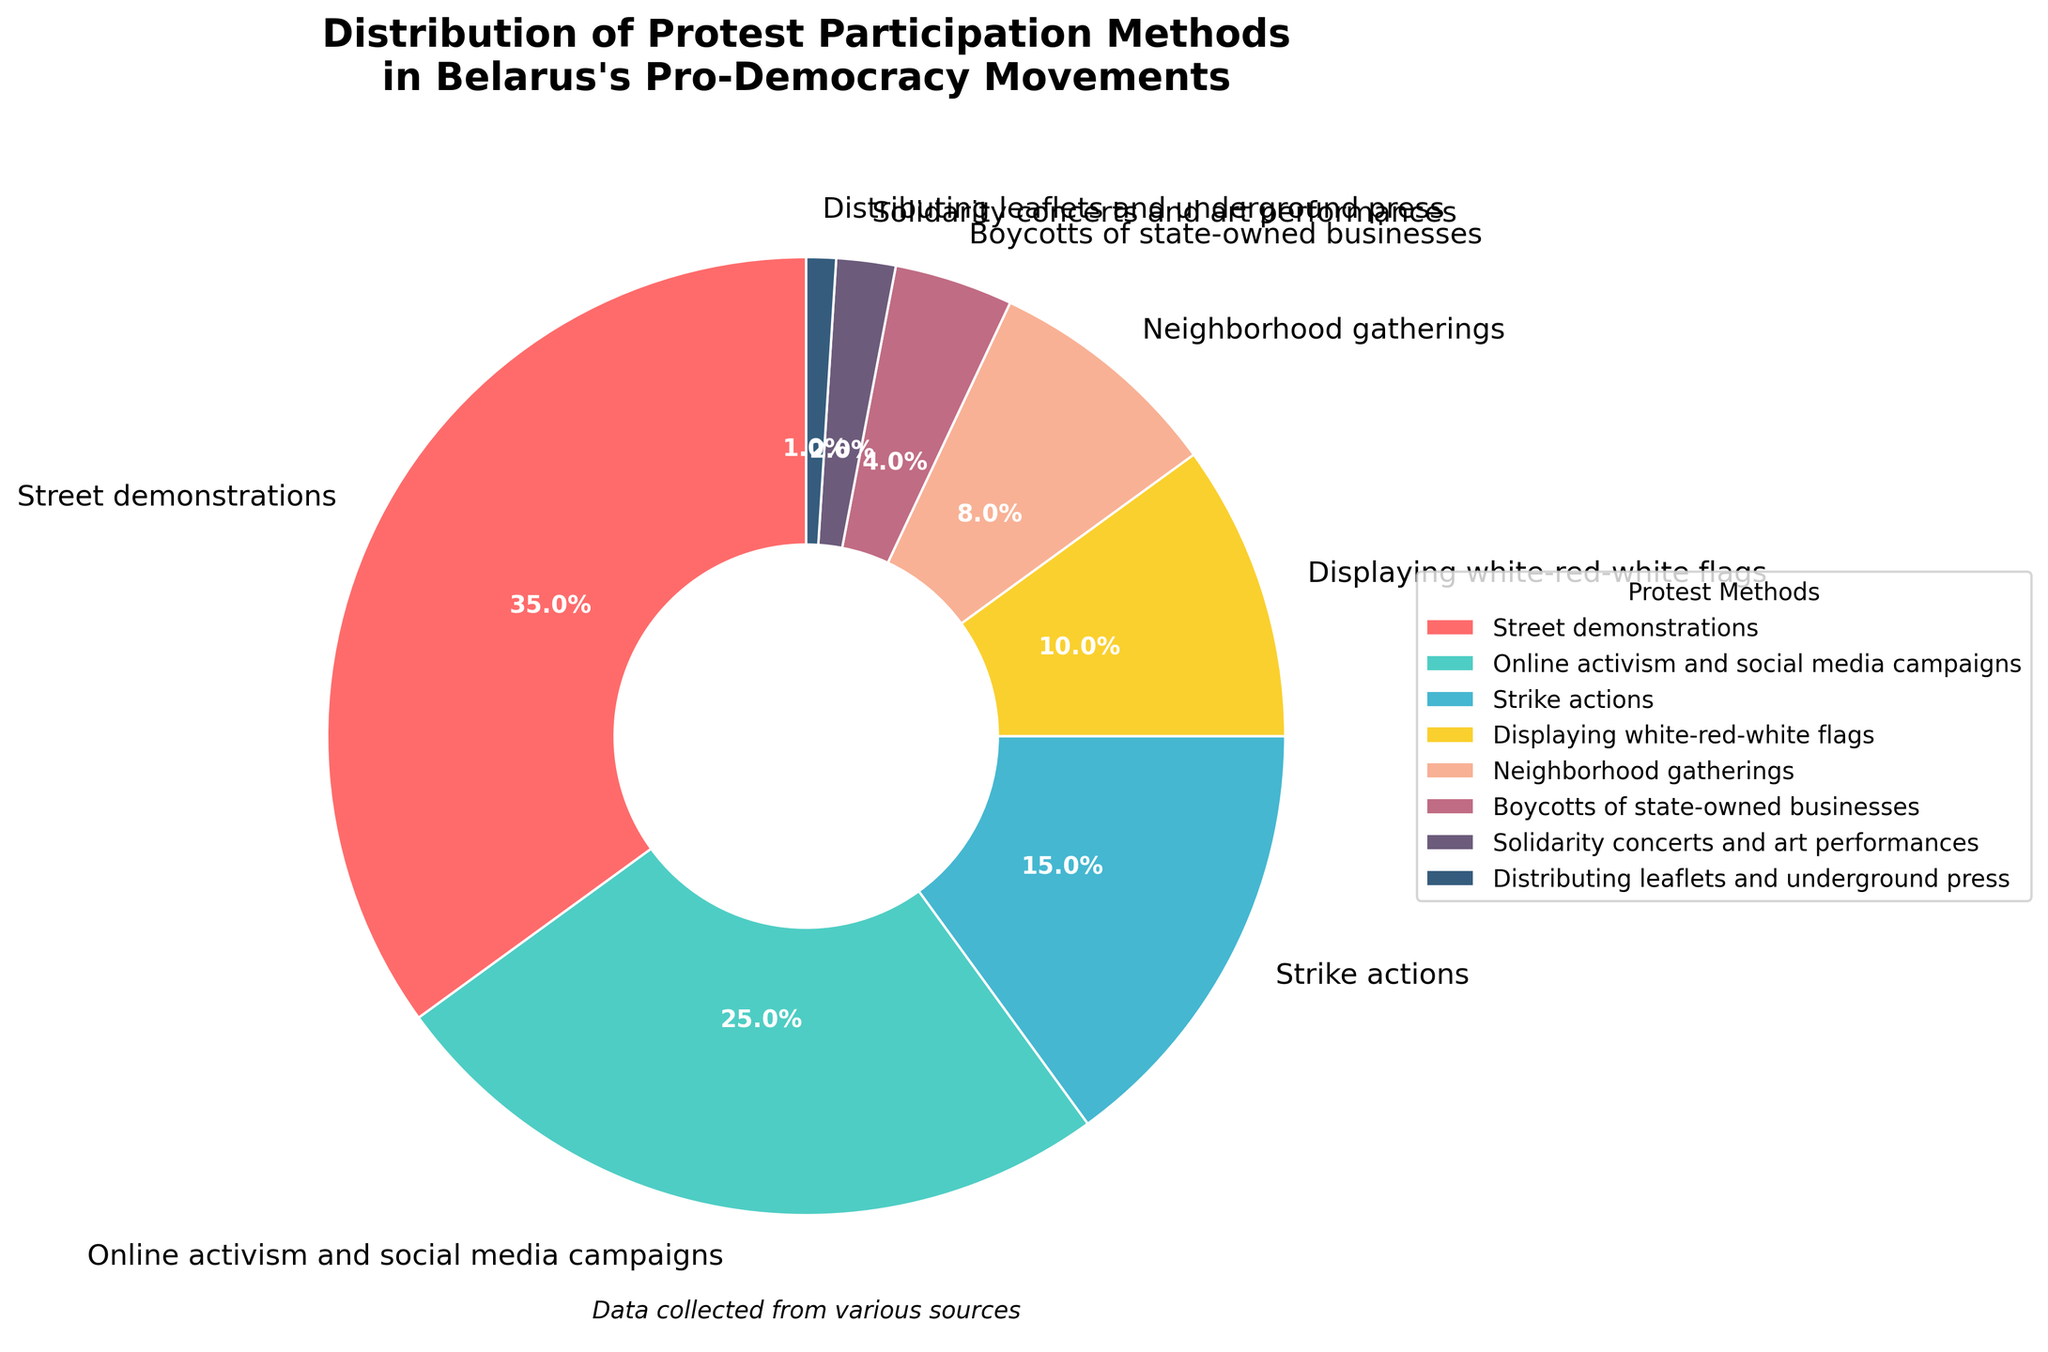Which protest participation method is the most common in Belarus's pro-democracy movements? The pie chart shows that the method with the largest slice, labeled "Street demonstrations," accounts for the highest percentage.
Answer: Street demonstrations Which protest method accounts for the smallest percentage of participation? The pie chart indicates that the smallest slice, labeled "Distributing leaflets and underground press," represents the lowest percentage.
Answer: Distributing leaflets and underground press How much more prevalent are street demonstrations compared to boycotts of state-owned businesses? Street demonstrations account for 35% of the total, while boycotts of state-owned businesses account for 4%. The difference is 35% - 4%.
Answer: 31% What is the combined percentage of online activism and social media campaigns and strike actions? Online activism and social media campaigns constitute 25%, while strike actions account for 15%. Adding these percentages yields 25% + 15%.
Answer: 40% Which two protest methods together exceed neighborhood gatherings but are less than strike actions? Neighborhood gatherings account for 8%, and we need two protest methods whose combined percentages exceed this but are less than the 15% for strike actions. Solidarity concerts and art performances (2%) and boycotts of state-owned businesses (4%) together make 2% + 4% = 6%, which is less than 8%. Adding displaying white-red-white flags (10%) would exceed strike actions (10% + 2%) and (10% + 4%). Ultimately, displaying white-red-white flags (10%) and neighborhood gatherings (8%) perfectly suit the constraints.
Answer: Displaying white-red-white flags and neighborhood gatherings Which protest methods are represented by slices with a reddish tone? The reddish colors in the pie chart are used for "Street demonstrations" and "Displaying white-red-white flags."
Answer: Street demonstrations and Displaying white-red-white flags How much greater is the percentage of displaying white-red-white flags than distributing leaflets and underground press? Displaying white-red-white flags is 10%, and distributing leaflets and underground press is 1%. The difference is 10% - 1%.
Answer: 9% What is the proportion of the solidarity concerts and art performances to the total street demonstrations? Solidarity concerts and art performances account for 2%, while street demonstrations account for 35%. The proportion is 2% / 35%.
Answer: 2/35 If the percentages of displaying white-red-white flags and neighborhood gatherings are combined, will their total exceed that of online activism and social media campaigns? Displaying white-red-white flags make up 10%, and neighborhood gatherings account for 8%. Their total is 10% + 8% = 18%. This is less than the 25% for online activism and social media campaigns.
Answer: No Which three protest methods together account for exactly half of the total participation? The following three percentages together form exactly half: Street demonstrations (35%), online activism and social media campaigns (25%), strike actions (15%). Summing these percentages results in 35% + 25% + 15% = 50%.
Answer: Street demonstrations, Online activism and social media campaigns, and Strike actions 